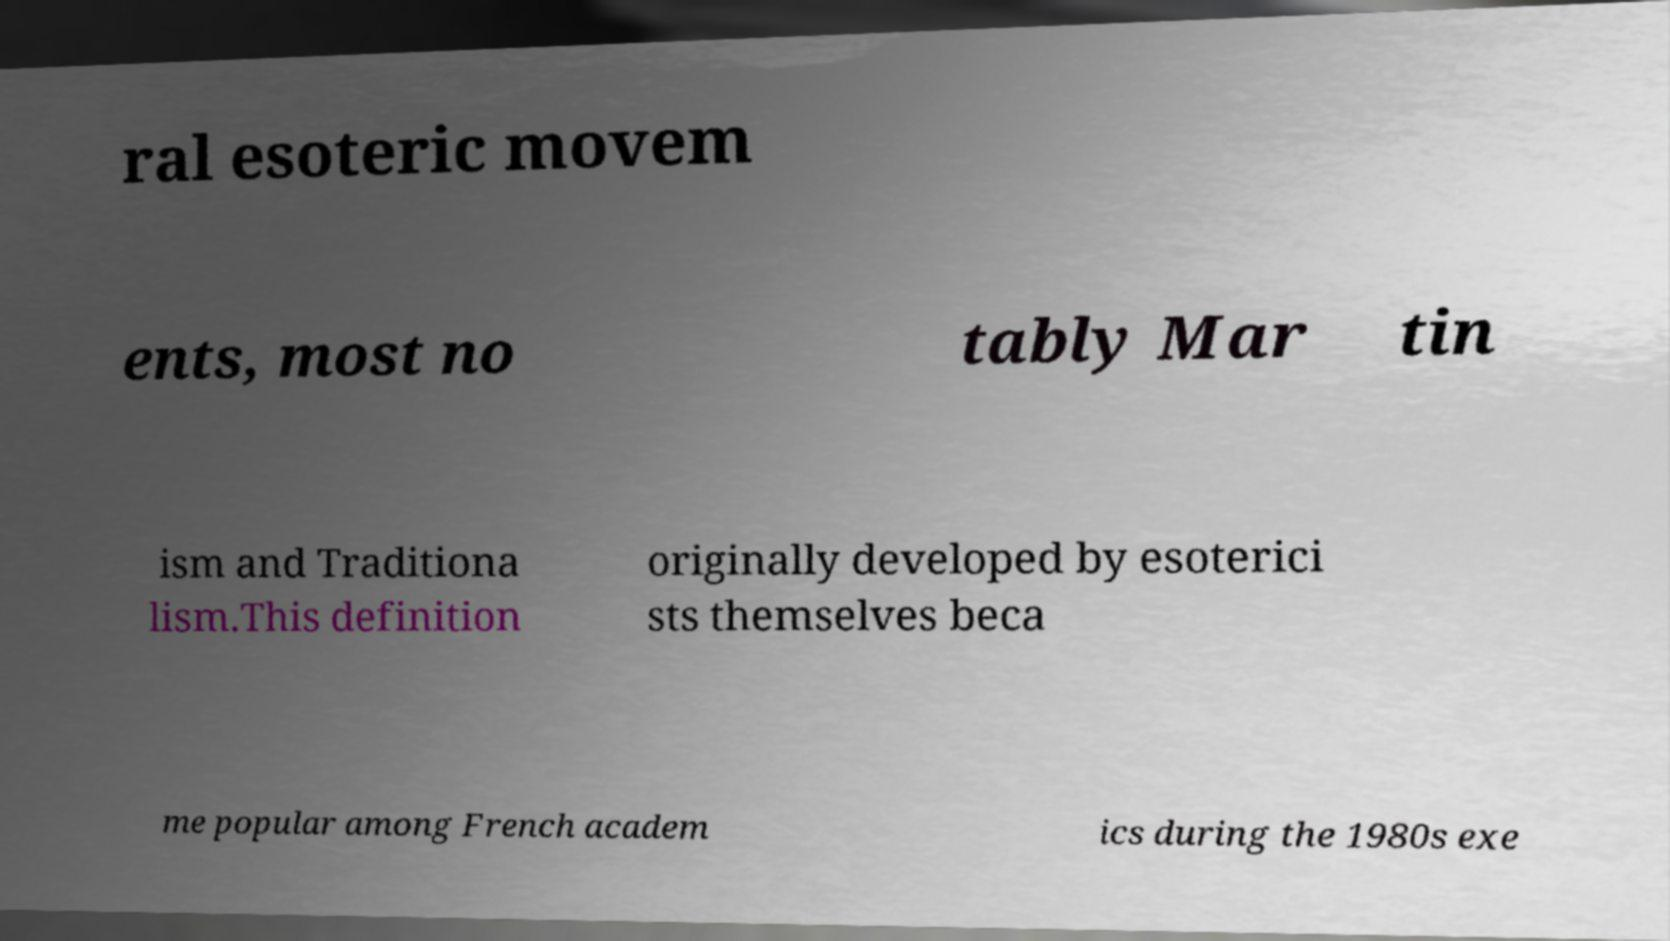For documentation purposes, I need the text within this image transcribed. Could you provide that? ral esoteric movem ents, most no tably Mar tin ism and Traditiona lism.This definition originally developed by esoterici sts themselves beca me popular among French academ ics during the 1980s exe 